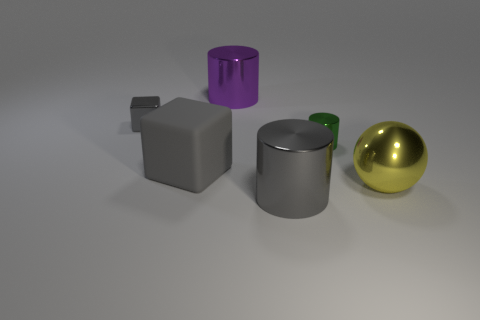Subtract all large cylinders. How many cylinders are left? 1 Subtract 2 cylinders. How many cylinders are left? 1 Subtract all gray cylinders. How many cylinders are left? 2 Add 3 tiny yellow cubes. How many objects exist? 9 Subtract all cubes. How many objects are left? 4 Add 1 gray blocks. How many gray blocks are left? 3 Add 3 small red cylinders. How many small red cylinders exist? 3 Subtract 0 cyan cubes. How many objects are left? 6 Subtract all green balls. Subtract all red cubes. How many balls are left? 1 Subtract all blue cylinders. How many brown blocks are left? 0 